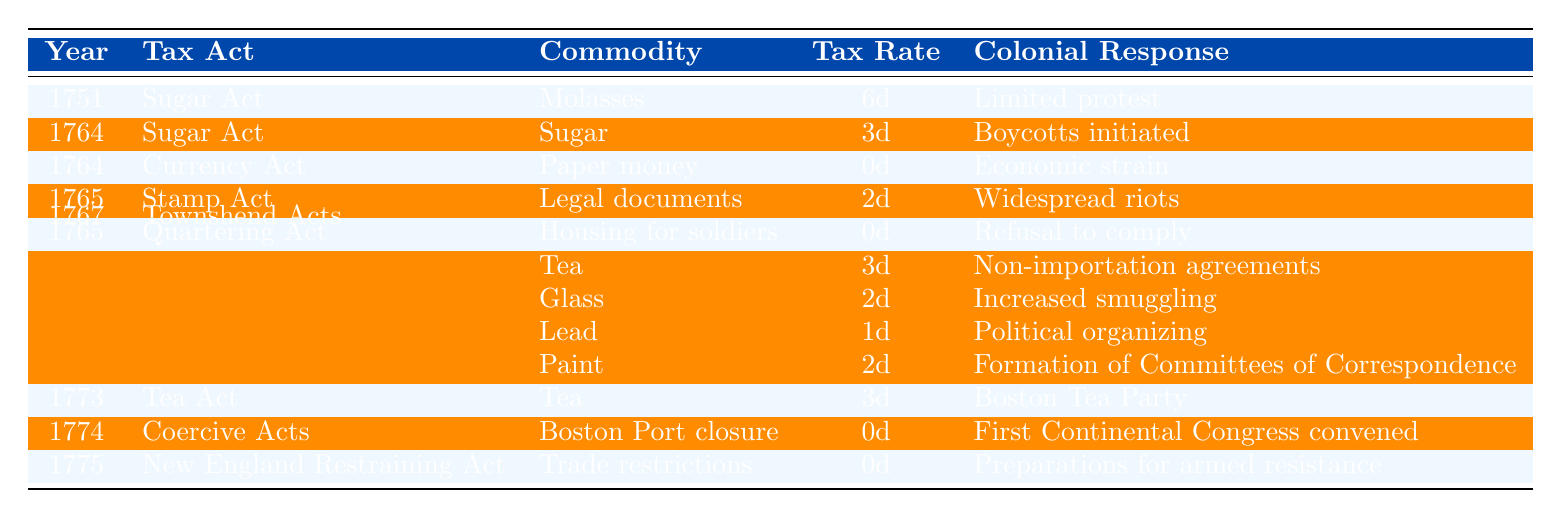What was the tax rate on molasses in 1751? The table indicates that the tax rate on molasses under the Sugar Act in 1751 was 6 pence.
Answer: 6 pence Which tax act imposed a tax rate of 2 pence? The Stamp Act imposed a tax rate of 2 pence on legal documents in 1765.
Answer: Stamp Act How many years had a tax rate of 0 pence from the table? The Currency Act (1764), Quartering Act (1765), Coercive Acts (1774), and New England Restraining Act (1775) all imposed a tax rate of 0 pence, totaling four years.
Answer: 4 years What was the colonial response to the Tea Act in 1773? The table states that the colonial response to the Tea Act in 1773 was the Boston Tea Party.
Answer: Boston Tea Party Which commodity had the highest tax rate in the table? Molasses had the highest tax rate of 6 pence in 1751, as shown in the table.
Answer: Molasses What was the average tax rate imposed by the Townshend Acts? The Townshend Acts taxed tea at 3 pence, glass at 2 pence, lead at 1 pence, and paint at 2 pence. The average tax rate is (3 + 2 + 1 + 2) / 4 = 1.5 pence.
Answer: 1.5 pence Did any of the tax acts have a tax rate greater than 6 pence? According to the table, the highest tax rate is 6 pence, imposed on molasses, and no other tax act exceeded this rate.
Answer: No What were the responses of the colonies in 1767 to the Townshend Acts? The colonies responded with non-importation agreements for tea, increased smuggling for glass, political organizing for lead, and the formation of Committees of Correspondence for paint in 1767. This indicates a multifaceted colonial resistance.
Answer: Multifaceted resistance In which year did the First Continental Congress convene in response to a tax act? The First Continental Congress convened in 1774 as a response to the Coercive Acts, which imposed no tax.
Answer: 1774 What is the difference in tax rate between the Stamp Act and the Tea Act? The Stamp Act had a tax rate of 2 pence, and the Tea Act had a rate of 3 pence. The difference is 3 pence - 2 pence = 1 pence.
Answer: 1 pence 